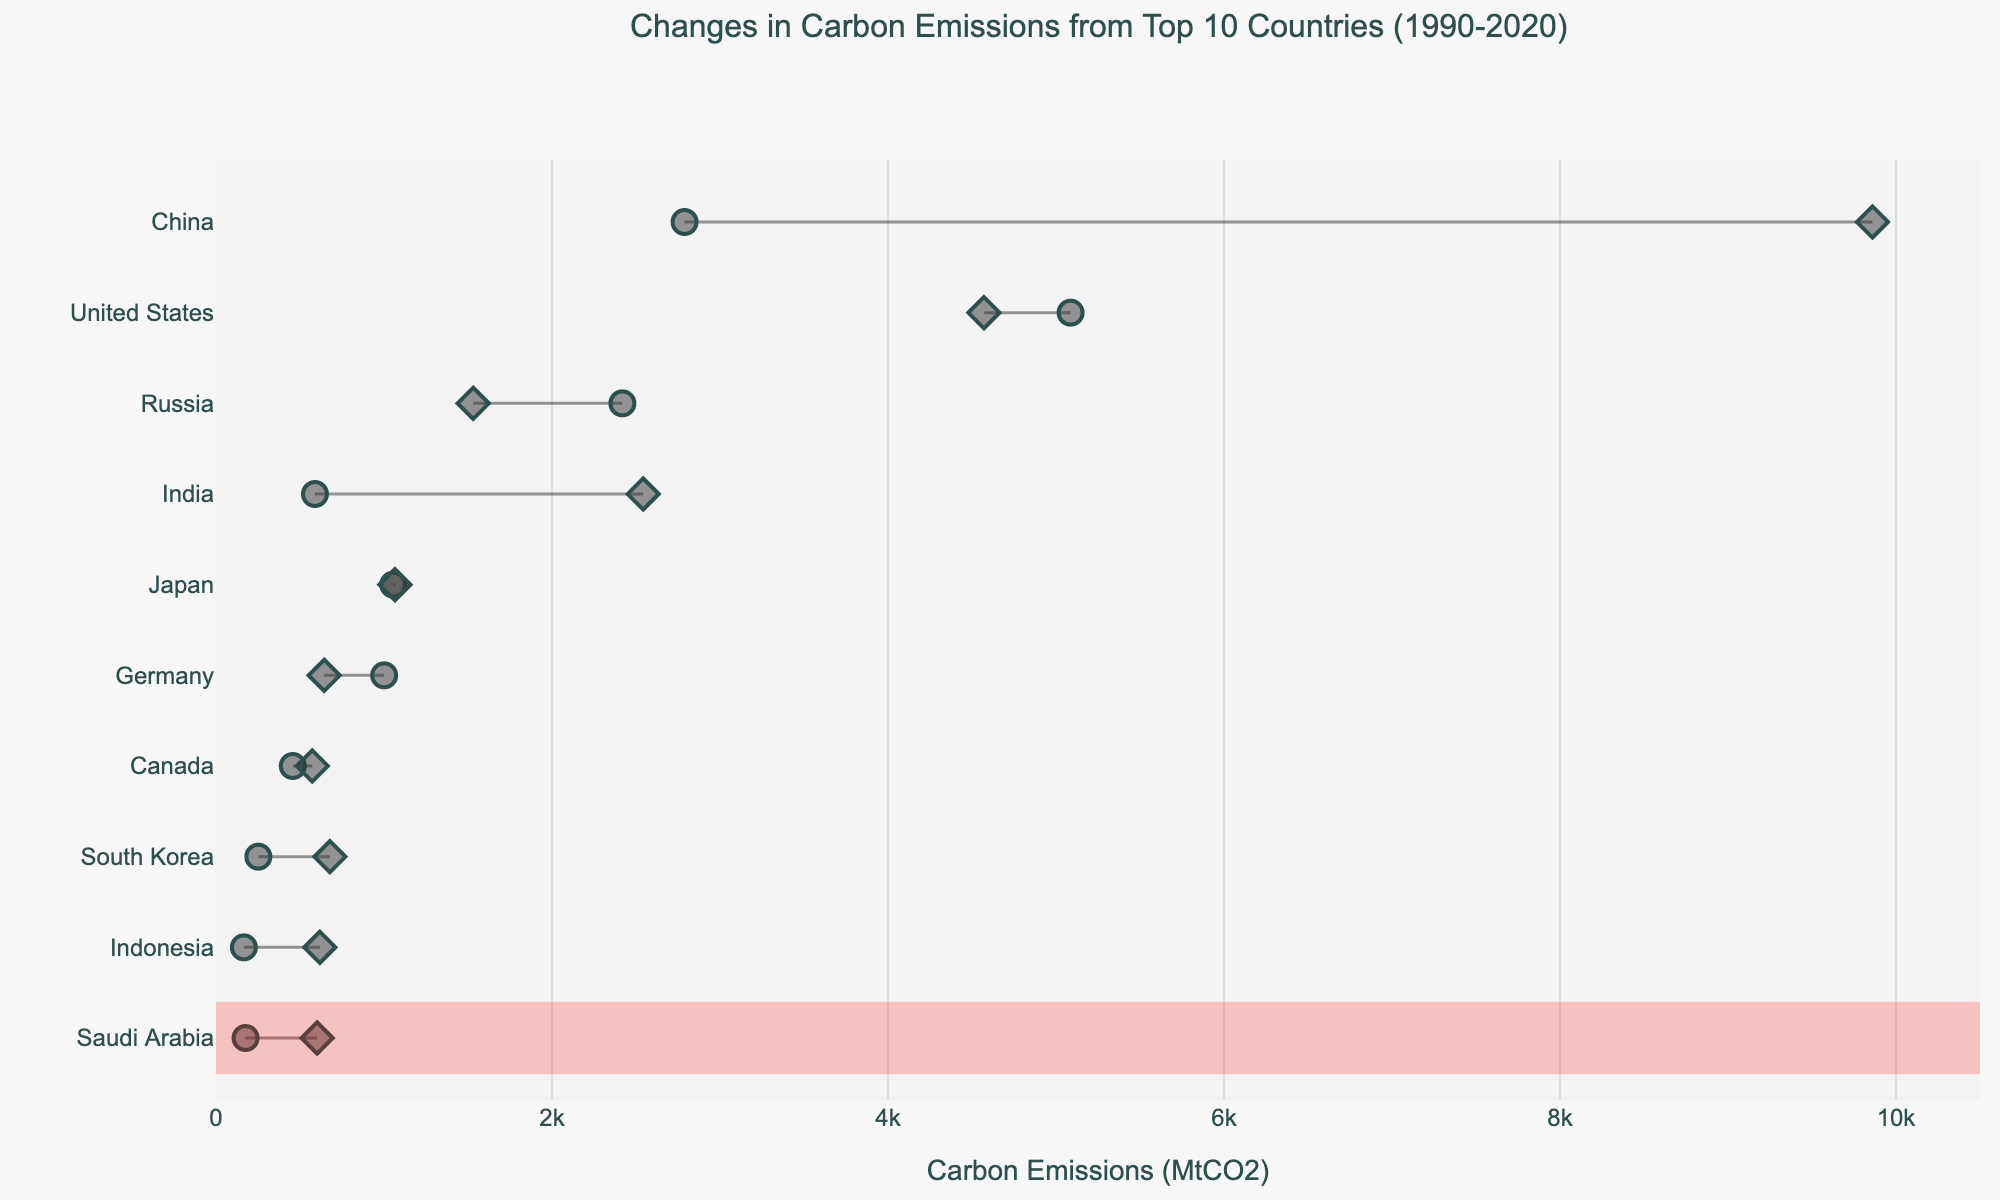How many countries are shown in the plot? The figure has markers and lines representing each country. The title states "Top 10 Countries," and counting the y-axis labels confirms there are 10 country names listed.
Answer: 10 What are the units for the x-axis? The x-axis has the label 'Carbon Emissions (MtCO2)', so the units are metric tons of CO2 emissions (MtCO2).
Answer: Metric tons of CO2 Which country had the largest increase in carbon emissions between 1990 and 2020? Looking at the plot, China had the most significant difference between the starting (1990) and ending (2020) markers. The change was highlighted with a rectangle.
Answer: China What is the change in carbon emissions for Japan? The markers for Japan in the plot show stable emissions: 1055 MtCO2 in 1990 and 1065 MtCO2 in 2020. The difference is 1065 - 1055 = 10 MtCO2.
Answer: 10 MtCO2 Which country reduced its carbon emissions the most from 1990 to 2020? The plot shows Russia had the largest reduction, with emissions decreasing from 2419 MtCO2 to 1531 MtCO2, a decrease of 2419 - 1531 = 888 MtCO2.
Answer: Russia What is the total carbon emissions in 2020 for the countries listed? Sum the 2020 emissions from all countries: 9860 + 4571 + 2543 + 1531 + 1065 + 644 + 573 + 678 + 618 + 602 = 32585 MtCO2.
Answer: 32585 MtCO2 What can be said about the trend of carbon emissions for Germany? The plot shows markers for Germany at 1001 MtCO2 in 1990 and 644 MtCO2 in 2020, indicating a reduction.
Answer: Decreased Which country had the least carbon emissions increase between 1990 and 2020? Japan had the smallest increase, with only a 10 MtCO2 difference from 1055 MtCO2 in 1990 to 1065 MtCO2 in 2020.
Answer: Japan 